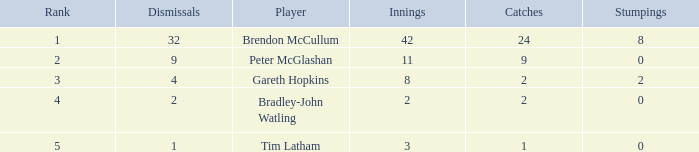How many stumpings did the player Tim Latham have? 0.0. 